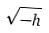<formula> <loc_0><loc_0><loc_500><loc_500>\sqrt { - h }</formula> 